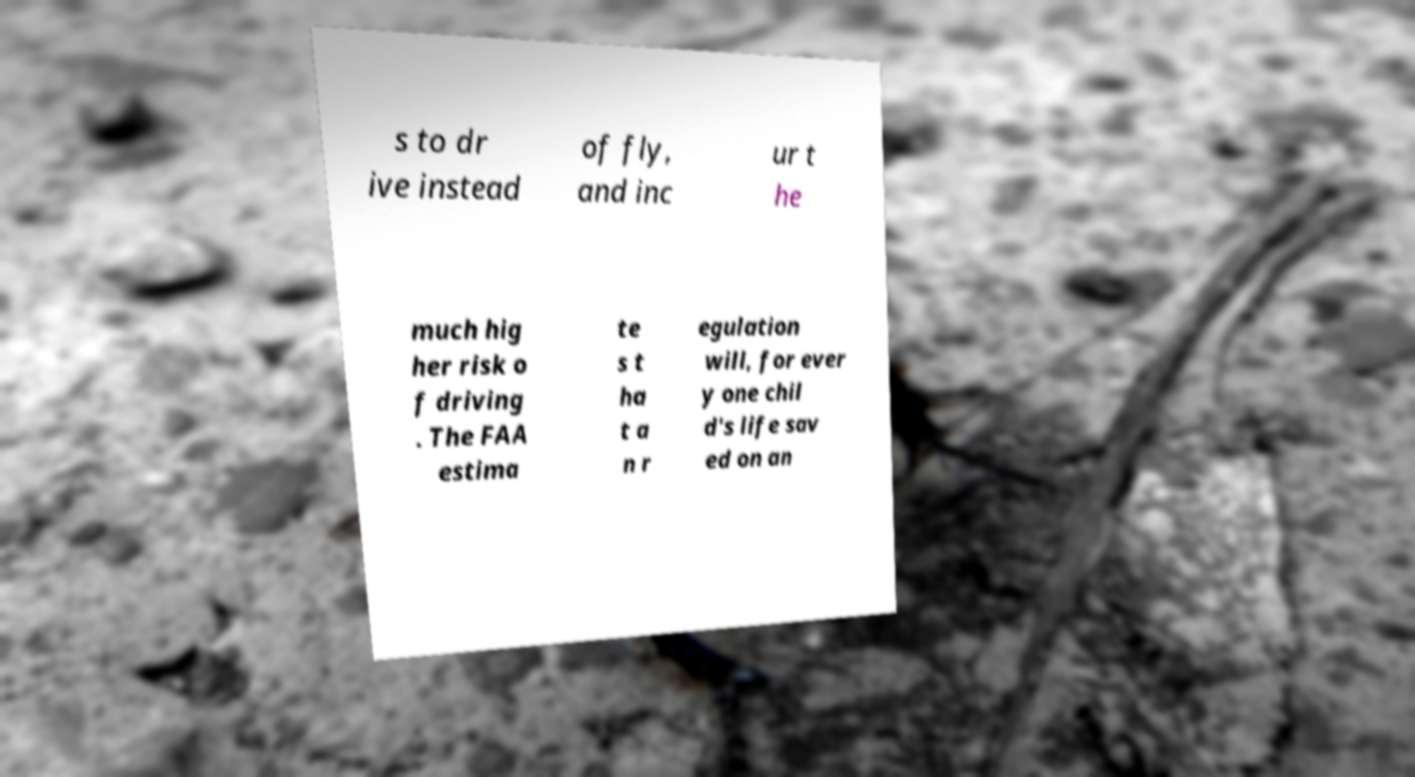Could you assist in decoding the text presented in this image and type it out clearly? s to dr ive instead of fly, and inc ur t he much hig her risk o f driving . The FAA estima te s t ha t a n r egulation will, for ever y one chil d's life sav ed on an 